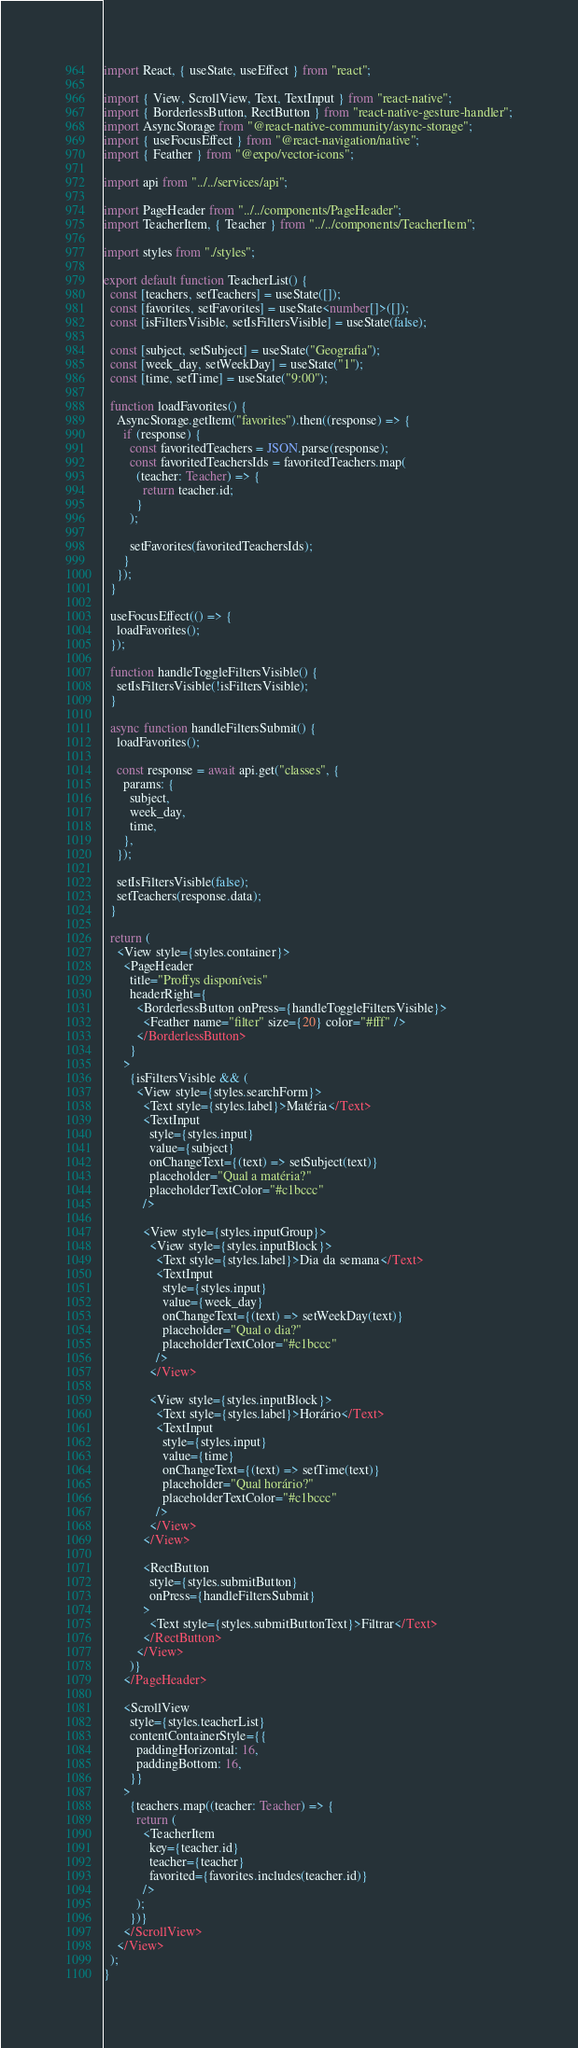Convert code to text. <code><loc_0><loc_0><loc_500><loc_500><_TypeScript_>import React, { useState, useEffect } from "react";

import { View, ScrollView, Text, TextInput } from "react-native";
import { BorderlessButton, RectButton } from "react-native-gesture-handler";
import AsyncStorage from "@react-native-community/async-storage";
import { useFocusEffect } from "@react-navigation/native";
import { Feather } from "@expo/vector-icons";

import api from "../../services/api";

import PageHeader from "../../components/PageHeader";
import TeacherItem, { Teacher } from "../../components/TeacherItem";

import styles from "./styles";

export default function TeacherList() {
  const [teachers, setTeachers] = useState([]);
  const [favorites, setFavorites] = useState<number[]>([]);
  const [isFiltersVisible, setIsFiltersVisible] = useState(false);

  const [subject, setSubject] = useState("Geografia");
  const [week_day, setWeekDay] = useState("1");
  const [time, setTime] = useState("9:00");

  function loadFavorites() {
    AsyncStorage.getItem("favorites").then((response) => {
      if (response) {
        const favoritedTeachers = JSON.parse(response);
        const favoritedTeachersIds = favoritedTeachers.map(
          (teacher: Teacher) => {
            return teacher.id;
          }
        );

        setFavorites(favoritedTeachersIds);
      }
    });
  }

  useFocusEffect(() => {
    loadFavorites();
  });

  function handleToggleFiltersVisible() {
    setIsFiltersVisible(!isFiltersVisible);
  }

  async function handleFiltersSubmit() {
    loadFavorites();

    const response = await api.get("classes", {
      params: {
        subject,
        week_day,
        time,
      },
    });

    setIsFiltersVisible(false);
    setTeachers(response.data);
  }

  return (
    <View style={styles.container}>
      <PageHeader
        title="Proffys disponíveis"
        headerRight={
          <BorderlessButton onPress={handleToggleFiltersVisible}>
            <Feather name="filter" size={20} color="#fff" />
          </BorderlessButton>
        }
      >
        {isFiltersVisible && (
          <View style={styles.searchForm}>
            <Text style={styles.label}>Matéria</Text>
            <TextInput
              style={styles.input}
              value={subject}
              onChangeText={(text) => setSubject(text)}
              placeholder="Qual a matéria?"
              placeholderTextColor="#c1bccc"
            />

            <View style={styles.inputGroup}>
              <View style={styles.inputBlock}>
                <Text style={styles.label}>Dia da semana</Text>
                <TextInput
                  style={styles.input}
                  value={week_day}
                  onChangeText={(text) => setWeekDay(text)}
                  placeholder="Qual o dia?"
                  placeholderTextColor="#c1bccc"
                />
              </View>

              <View style={styles.inputBlock}>
                <Text style={styles.label}>Horário</Text>
                <TextInput
                  style={styles.input}
                  value={time}
                  onChangeText={(text) => setTime(text)}
                  placeholder="Qual horário?"
                  placeholderTextColor="#c1bccc"
                />
              </View>
            </View>

            <RectButton
              style={styles.submitButton}
              onPress={handleFiltersSubmit}
            >
              <Text style={styles.submitButtonText}>Filtrar</Text>
            </RectButton>
          </View>
        )}
      </PageHeader>

      <ScrollView
        style={styles.teacherList}
        contentContainerStyle={{
          paddingHorizontal: 16,
          paddingBottom: 16,
        }}
      >
        {teachers.map((teacher: Teacher) => {
          return (
            <TeacherItem
              key={teacher.id}
              teacher={teacher}
              favorited={favorites.includes(teacher.id)}
            />
          );
        })}
      </ScrollView>
    </View>
  );
}
</code> 